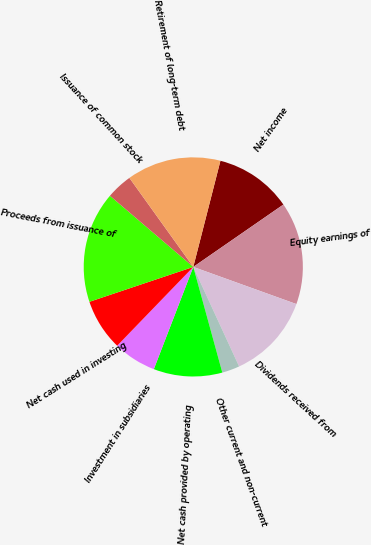Convert chart to OTSL. <chart><loc_0><loc_0><loc_500><loc_500><pie_chart><fcel>Net income<fcel>Equity earnings of<fcel>Dividends received from<fcel>Other current and non-current<fcel>Net cash provided by operating<fcel>Investment in subsidiaries<fcel>Net cash used in investing<fcel>Proceeds from issuance of<fcel>Issuance of common stock<fcel>Retirement of long-term debt<nl><fcel>11.38%<fcel>15.14%<fcel>12.63%<fcel>2.6%<fcel>10.13%<fcel>6.36%<fcel>7.62%<fcel>16.4%<fcel>3.85%<fcel>13.89%<nl></chart> 